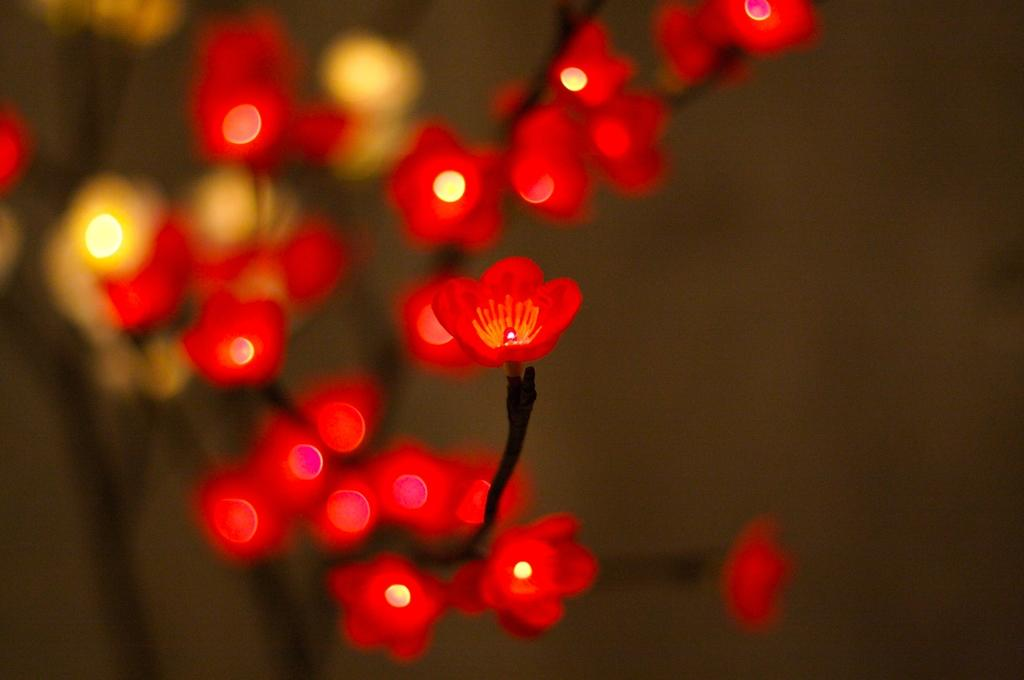What type of flower can be seen in the picture? There is a red flower in the picture. What else is present in the picture besides the flower? There appears to be a light in the picture. Can you describe the background of the image? The background of the image is blurred. Where is the bear located in the picture? There is no bear present in the picture. What type of line can be seen connecting the flower and the sink in the image? There is no sink or line connecting the flower and any other object in the image. 